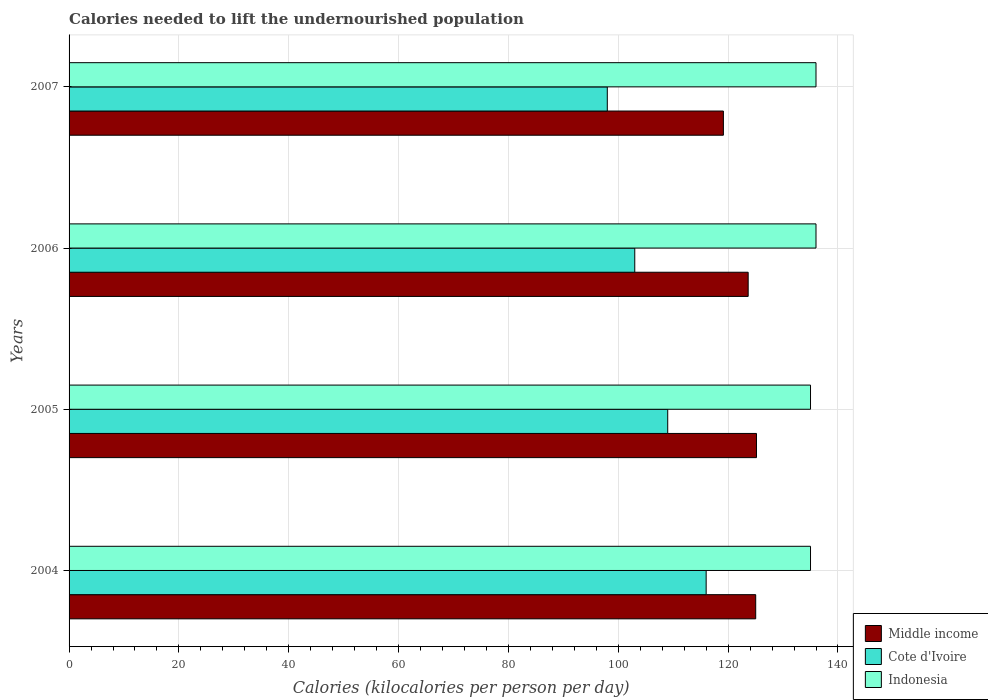How many bars are there on the 1st tick from the top?
Ensure brevity in your answer.  3. What is the total calories needed to lift the undernourished population in Middle income in 2006?
Provide a short and direct response. 123.65. Across all years, what is the maximum total calories needed to lift the undernourished population in Indonesia?
Your answer should be very brief. 136. Across all years, what is the minimum total calories needed to lift the undernourished population in Cote d'Ivoire?
Offer a very short reply. 98. In which year was the total calories needed to lift the undernourished population in Indonesia maximum?
Keep it short and to the point. 2006. What is the total total calories needed to lift the undernourished population in Middle income in the graph?
Provide a succinct answer. 492.97. What is the difference between the total calories needed to lift the undernourished population in Indonesia in 2004 and that in 2007?
Provide a short and direct response. -1. What is the difference between the total calories needed to lift the undernourished population in Middle income in 2004 and the total calories needed to lift the undernourished population in Indonesia in 2006?
Your answer should be compact. -10.98. What is the average total calories needed to lift the undernourished population in Cote d'Ivoire per year?
Provide a succinct answer. 106.5. In the year 2004, what is the difference between the total calories needed to lift the undernourished population in Cote d'Ivoire and total calories needed to lift the undernourished population in Middle income?
Provide a succinct answer. -9.02. What is the difference between the highest and the second highest total calories needed to lift the undernourished population in Middle income?
Make the answer very short. 0.14. What is the difference between the highest and the lowest total calories needed to lift the undernourished population in Cote d'Ivoire?
Provide a short and direct response. 18. In how many years, is the total calories needed to lift the undernourished population in Middle income greater than the average total calories needed to lift the undernourished population in Middle income taken over all years?
Offer a terse response. 3. Is the sum of the total calories needed to lift the undernourished population in Middle income in 2006 and 2007 greater than the maximum total calories needed to lift the undernourished population in Indonesia across all years?
Your answer should be compact. Yes. What does the 3rd bar from the top in 2005 represents?
Give a very brief answer. Middle income. What does the 3rd bar from the bottom in 2006 represents?
Provide a short and direct response. Indonesia. How many bars are there?
Provide a succinct answer. 12. How many years are there in the graph?
Provide a short and direct response. 4. What is the difference between two consecutive major ticks on the X-axis?
Your answer should be compact. 20. Are the values on the major ticks of X-axis written in scientific E-notation?
Provide a short and direct response. No. Where does the legend appear in the graph?
Give a very brief answer. Bottom right. How are the legend labels stacked?
Give a very brief answer. Vertical. What is the title of the graph?
Your answer should be compact. Calories needed to lift the undernourished population. Does "Norway" appear as one of the legend labels in the graph?
Ensure brevity in your answer.  No. What is the label or title of the X-axis?
Your answer should be compact. Calories (kilocalories per person per day). What is the label or title of the Y-axis?
Offer a very short reply. Years. What is the Calories (kilocalories per person per day) of Middle income in 2004?
Ensure brevity in your answer.  125.02. What is the Calories (kilocalories per person per day) of Cote d'Ivoire in 2004?
Your answer should be compact. 116. What is the Calories (kilocalories per person per day) in Indonesia in 2004?
Offer a terse response. 135. What is the Calories (kilocalories per person per day) of Middle income in 2005?
Your response must be concise. 125.16. What is the Calories (kilocalories per person per day) in Cote d'Ivoire in 2005?
Ensure brevity in your answer.  109. What is the Calories (kilocalories per person per day) of Indonesia in 2005?
Your answer should be very brief. 135. What is the Calories (kilocalories per person per day) in Middle income in 2006?
Your answer should be very brief. 123.65. What is the Calories (kilocalories per person per day) in Cote d'Ivoire in 2006?
Ensure brevity in your answer.  103. What is the Calories (kilocalories per person per day) in Indonesia in 2006?
Offer a very short reply. 136. What is the Calories (kilocalories per person per day) in Middle income in 2007?
Your response must be concise. 119.14. What is the Calories (kilocalories per person per day) in Indonesia in 2007?
Give a very brief answer. 136. Across all years, what is the maximum Calories (kilocalories per person per day) of Middle income?
Provide a short and direct response. 125.16. Across all years, what is the maximum Calories (kilocalories per person per day) of Cote d'Ivoire?
Ensure brevity in your answer.  116. Across all years, what is the maximum Calories (kilocalories per person per day) in Indonesia?
Offer a very short reply. 136. Across all years, what is the minimum Calories (kilocalories per person per day) in Middle income?
Make the answer very short. 119.14. Across all years, what is the minimum Calories (kilocalories per person per day) in Indonesia?
Ensure brevity in your answer.  135. What is the total Calories (kilocalories per person per day) in Middle income in the graph?
Provide a short and direct response. 492.97. What is the total Calories (kilocalories per person per day) in Cote d'Ivoire in the graph?
Provide a short and direct response. 426. What is the total Calories (kilocalories per person per day) of Indonesia in the graph?
Your answer should be very brief. 542. What is the difference between the Calories (kilocalories per person per day) in Middle income in 2004 and that in 2005?
Keep it short and to the point. -0.14. What is the difference between the Calories (kilocalories per person per day) in Indonesia in 2004 and that in 2005?
Offer a terse response. 0. What is the difference between the Calories (kilocalories per person per day) in Middle income in 2004 and that in 2006?
Offer a very short reply. 1.37. What is the difference between the Calories (kilocalories per person per day) of Middle income in 2004 and that in 2007?
Provide a succinct answer. 5.88. What is the difference between the Calories (kilocalories per person per day) in Middle income in 2005 and that in 2006?
Provide a short and direct response. 1.51. What is the difference between the Calories (kilocalories per person per day) in Cote d'Ivoire in 2005 and that in 2006?
Offer a very short reply. 6. What is the difference between the Calories (kilocalories per person per day) in Middle income in 2005 and that in 2007?
Offer a very short reply. 6.03. What is the difference between the Calories (kilocalories per person per day) in Indonesia in 2005 and that in 2007?
Your answer should be compact. -1. What is the difference between the Calories (kilocalories per person per day) of Middle income in 2006 and that in 2007?
Offer a very short reply. 4.51. What is the difference between the Calories (kilocalories per person per day) of Middle income in 2004 and the Calories (kilocalories per person per day) of Cote d'Ivoire in 2005?
Your answer should be very brief. 16.02. What is the difference between the Calories (kilocalories per person per day) in Middle income in 2004 and the Calories (kilocalories per person per day) in Indonesia in 2005?
Your answer should be very brief. -9.98. What is the difference between the Calories (kilocalories per person per day) in Cote d'Ivoire in 2004 and the Calories (kilocalories per person per day) in Indonesia in 2005?
Keep it short and to the point. -19. What is the difference between the Calories (kilocalories per person per day) of Middle income in 2004 and the Calories (kilocalories per person per day) of Cote d'Ivoire in 2006?
Provide a short and direct response. 22.02. What is the difference between the Calories (kilocalories per person per day) in Middle income in 2004 and the Calories (kilocalories per person per day) in Indonesia in 2006?
Provide a short and direct response. -10.98. What is the difference between the Calories (kilocalories per person per day) of Cote d'Ivoire in 2004 and the Calories (kilocalories per person per day) of Indonesia in 2006?
Your answer should be compact. -20. What is the difference between the Calories (kilocalories per person per day) in Middle income in 2004 and the Calories (kilocalories per person per day) in Cote d'Ivoire in 2007?
Your answer should be very brief. 27.02. What is the difference between the Calories (kilocalories per person per day) in Middle income in 2004 and the Calories (kilocalories per person per day) in Indonesia in 2007?
Your answer should be very brief. -10.98. What is the difference between the Calories (kilocalories per person per day) of Cote d'Ivoire in 2004 and the Calories (kilocalories per person per day) of Indonesia in 2007?
Offer a terse response. -20. What is the difference between the Calories (kilocalories per person per day) in Middle income in 2005 and the Calories (kilocalories per person per day) in Cote d'Ivoire in 2006?
Provide a short and direct response. 22.16. What is the difference between the Calories (kilocalories per person per day) of Middle income in 2005 and the Calories (kilocalories per person per day) of Indonesia in 2006?
Your answer should be compact. -10.84. What is the difference between the Calories (kilocalories per person per day) in Middle income in 2005 and the Calories (kilocalories per person per day) in Cote d'Ivoire in 2007?
Keep it short and to the point. 27.16. What is the difference between the Calories (kilocalories per person per day) in Middle income in 2005 and the Calories (kilocalories per person per day) in Indonesia in 2007?
Your response must be concise. -10.84. What is the difference between the Calories (kilocalories per person per day) in Middle income in 2006 and the Calories (kilocalories per person per day) in Cote d'Ivoire in 2007?
Ensure brevity in your answer.  25.65. What is the difference between the Calories (kilocalories per person per day) in Middle income in 2006 and the Calories (kilocalories per person per day) in Indonesia in 2007?
Your answer should be very brief. -12.35. What is the difference between the Calories (kilocalories per person per day) of Cote d'Ivoire in 2006 and the Calories (kilocalories per person per day) of Indonesia in 2007?
Your response must be concise. -33. What is the average Calories (kilocalories per person per day) of Middle income per year?
Give a very brief answer. 123.24. What is the average Calories (kilocalories per person per day) of Cote d'Ivoire per year?
Make the answer very short. 106.5. What is the average Calories (kilocalories per person per day) in Indonesia per year?
Ensure brevity in your answer.  135.5. In the year 2004, what is the difference between the Calories (kilocalories per person per day) in Middle income and Calories (kilocalories per person per day) in Cote d'Ivoire?
Ensure brevity in your answer.  9.02. In the year 2004, what is the difference between the Calories (kilocalories per person per day) of Middle income and Calories (kilocalories per person per day) of Indonesia?
Provide a succinct answer. -9.98. In the year 2004, what is the difference between the Calories (kilocalories per person per day) in Cote d'Ivoire and Calories (kilocalories per person per day) in Indonesia?
Provide a short and direct response. -19. In the year 2005, what is the difference between the Calories (kilocalories per person per day) in Middle income and Calories (kilocalories per person per day) in Cote d'Ivoire?
Your response must be concise. 16.16. In the year 2005, what is the difference between the Calories (kilocalories per person per day) of Middle income and Calories (kilocalories per person per day) of Indonesia?
Ensure brevity in your answer.  -9.84. In the year 2005, what is the difference between the Calories (kilocalories per person per day) in Cote d'Ivoire and Calories (kilocalories per person per day) in Indonesia?
Make the answer very short. -26. In the year 2006, what is the difference between the Calories (kilocalories per person per day) in Middle income and Calories (kilocalories per person per day) in Cote d'Ivoire?
Make the answer very short. 20.65. In the year 2006, what is the difference between the Calories (kilocalories per person per day) of Middle income and Calories (kilocalories per person per day) of Indonesia?
Your response must be concise. -12.35. In the year 2006, what is the difference between the Calories (kilocalories per person per day) in Cote d'Ivoire and Calories (kilocalories per person per day) in Indonesia?
Your response must be concise. -33. In the year 2007, what is the difference between the Calories (kilocalories per person per day) in Middle income and Calories (kilocalories per person per day) in Cote d'Ivoire?
Ensure brevity in your answer.  21.14. In the year 2007, what is the difference between the Calories (kilocalories per person per day) in Middle income and Calories (kilocalories per person per day) in Indonesia?
Provide a short and direct response. -16.86. In the year 2007, what is the difference between the Calories (kilocalories per person per day) of Cote d'Ivoire and Calories (kilocalories per person per day) of Indonesia?
Keep it short and to the point. -38. What is the ratio of the Calories (kilocalories per person per day) of Middle income in 2004 to that in 2005?
Ensure brevity in your answer.  1. What is the ratio of the Calories (kilocalories per person per day) in Cote d'Ivoire in 2004 to that in 2005?
Make the answer very short. 1.06. What is the ratio of the Calories (kilocalories per person per day) of Middle income in 2004 to that in 2006?
Provide a short and direct response. 1.01. What is the ratio of the Calories (kilocalories per person per day) in Cote d'Ivoire in 2004 to that in 2006?
Provide a succinct answer. 1.13. What is the ratio of the Calories (kilocalories per person per day) in Indonesia in 2004 to that in 2006?
Keep it short and to the point. 0.99. What is the ratio of the Calories (kilocalories per person per day) of Middle income in 2004 to that in 2007?
Your answer should be very brief. 1.05. What is the ratio of the Calories (kilocalories per person per day) of Cote d'Ivoire in 2004 to that in 2007?
Ensure brevity in your answer.  1.18. What is the ratio of the Calories (kilocalories per person per day) of Middle income in 2005 to that in 2006?
Give a very brief answer. 1.01. What is the ratio of the Calories (kilocalories per person per day) in Cote d'Ivoire in 2005 to that in 2006?
Your answer should be very brief. 1.06. What is the ratio of the Calories (kilocalories per person per day) in Indonesia in 2005 to that in 2006?
Offer a very short reply. 0.99. What is the ratio of the Calories (kilocalories per person per day) in Middle income in 2005 to that in 2007?
Offer a terse response. 1.05. What is the ratio of the Calories (kilocalories per person per day) in Cote d'Ivoire in 2005 to that in 2007?
Make the answer very short. 1.11. What is the ratio of the Calories (kilocalories per person per day) of Indonesia in 2005 to that in 2007?
Your answer should be very brief. 0.99. What is the ratio of the Calories (kilocalories per person per day) in Middle income in 2006 to that in 2007?
Give a very brief answer. 1.04. What is the ratio of the Calories (kilocalories per person per day) of Cote d'Ivoire in 2006 to that in 2007?
Your response must be concise. 1.05. What is the ratio of the Calories (kilocalories per person per day) of Indonesia in 2006 to that in 2007?
Your response must be concise. 1. What is the difference between the highest and the second highest Calories (kilocalories per person per day) in Middle income?
Offer a terse response. 0.14. What is the difference between the highest and the second highest Calories (kilocalories per person per day) of Cote d'Ivoire?
Your response must be concise. 7. What is the difference between the highest and the second highest Calories (kilocalories per person per day) of Indonesia?
Your answer should be compact. 0. What is the difference between the highest and the lowest Calories (kilocalories per person per day) in Middle income?
Give a very brief answer. 6.03. What is the difference between the highest and the lowest Calories (kilocalories per person per day) of Indonesia?
Ensure brevity in your answer.  1. 